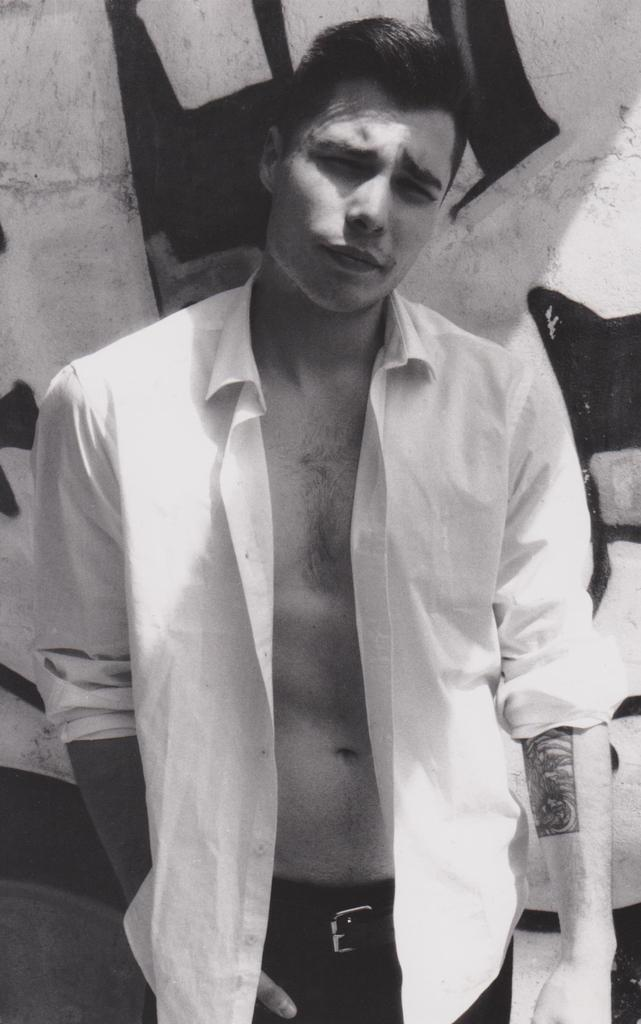What is the color scheme of the image? The image is black and white. Who is present in the image? There is a man in the image. What distinguishing feature can be seen on the man's hand? The man has a tattoo on his hand. What can be seen in the background of the image? There is a wall in the background of the image. What type of reward is the man receiving in the image? There is no indication in the image that the man is receiving a reward, so it cannot be determined from the picture. 